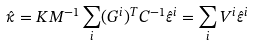Convert formula to latex. <formula><loc_0><loc_0><loc_500><loc_500>\hat { \kappa } = K M ^ { - 1 } \sum _ { i } ( G ^ { i } ) ^ { T } C ^ { - 1 } \hat { \varepsilon } ^ { i } = \sum _ { i } V ^ { i } \hat { \varepsilon } ^ { i }</formula> 